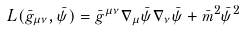<formula> <loc_0><loc_0><loc_500><loc_500>L ( \bar { g } _ { \mu \nu } , \bar { \psi } ) = \bar { g } ^ { \mu \nu } \nabla _ { \mu } \bar { \psi } \nabla _ { \nu } \bar { \psi } + \bar { m } ^ { 2 } \bar { \psi } ^ { 2 }</formula> 